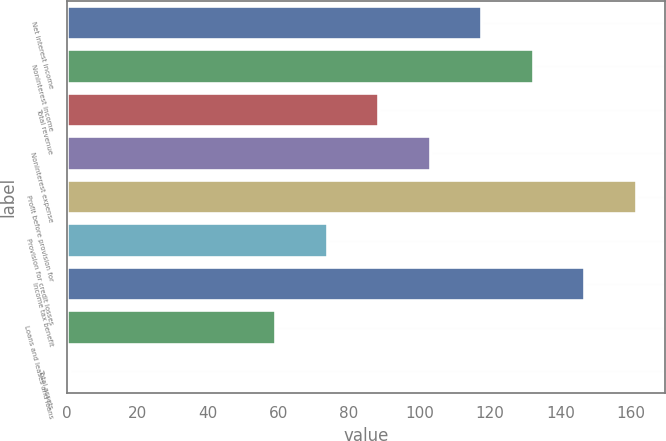Convert chart to OTSL. <chart><loc_0><loc_0><loc_500><loc_500><bar_chart><fcel>Net interest income<fcel>Noninterest income<fcel>Total revenue<fcel>Noninterest expense<fcel>Profit before provision for<fcel>Provision for credit losses<fcel>Income tax benefit<fcel>Loans and leases and loans<fcel>Total assets<nl><fcel>117.8<fcel>132.4<fcel>88.6<fcel>103.2<fcel>161.6<fcel>74<fcel>147<fcel>59.4<fcel>1<nl></chart> 